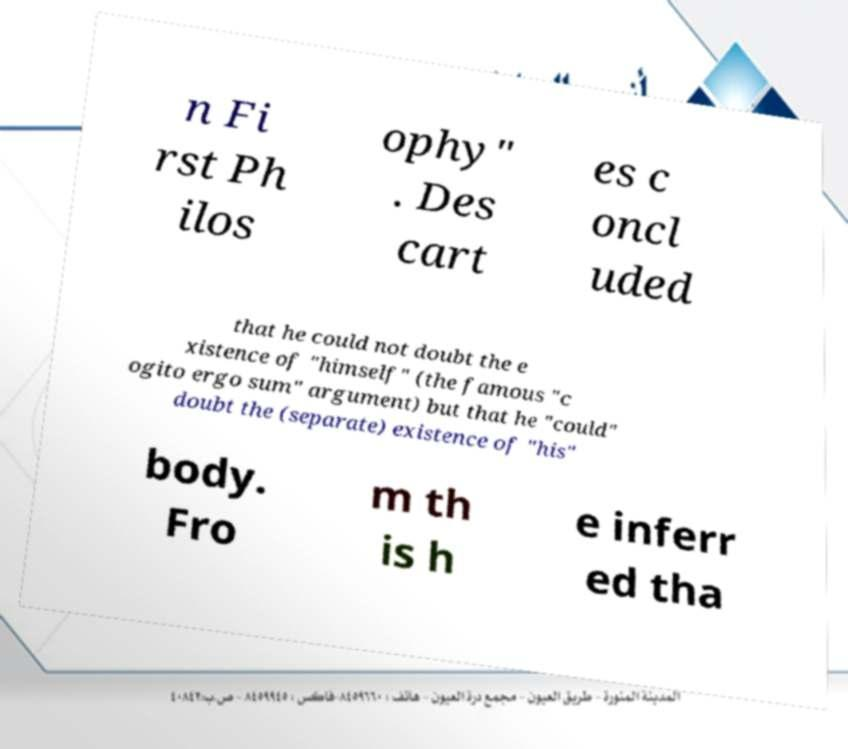There's text embedded in this image that I need extracted. Can you transcribe it verbatim? n Fi rst Ph ilos ophy" . Des cart es c oncl uded that he could not doubt the e xistence of "himself" (the famous "c ogito ergo sum" argument) but that he "could" doubt the (separate) existence of "his" body. Fro m th is h e inferr ed tha 